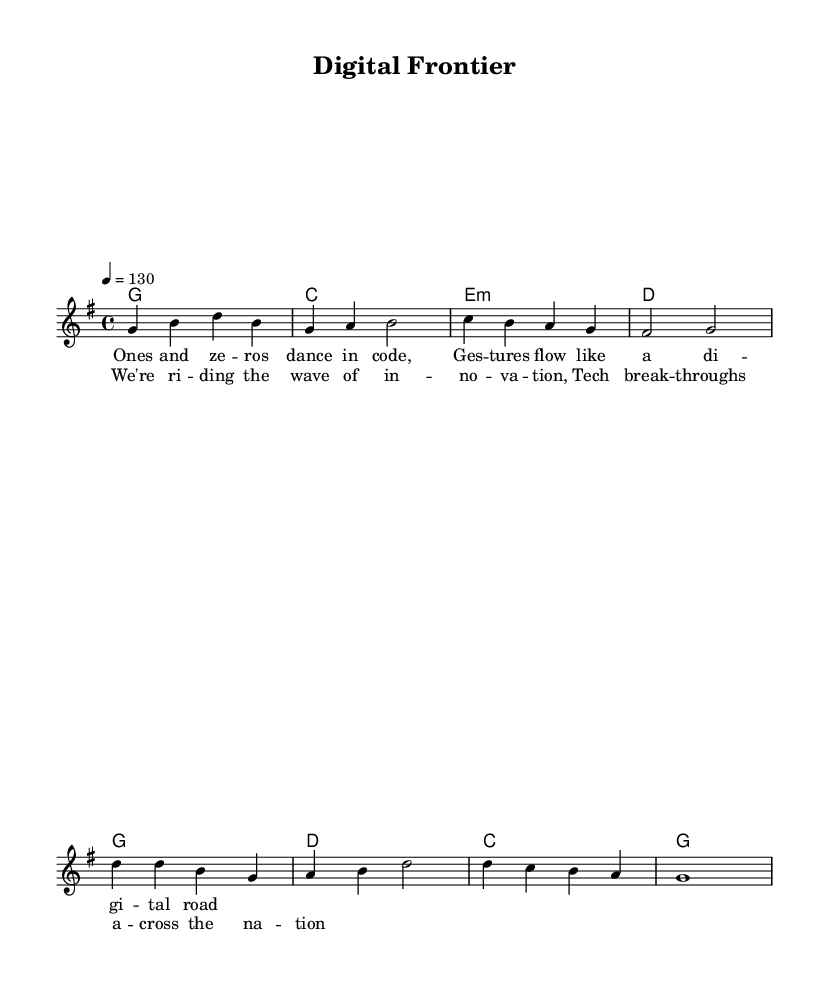What is the key signature of this music? The key signature is G major, indicated by one sharp (F#).
Answer: G major What is the time signature of this music? The time signature is 4/4, meaning there are four beats in each measure, and the quarter note gets one beat.
Answer: 4/4 What is the tempo marking for this piece? The tempo marking indicates a speed of 130 beats per minute, which is stated as "4 = 130."
Answer: 130 How many measures are there in the verse? The verse contains four measures as indicated by the line breaks in the melody section.
Answer: 4 Which chord follows the G chord in the chorus? The chord progression in the chorus indicates that the D chord follows the G chord.
Answer: D What lyrical theme is represented in this song? The song celebrates technological innovation and advances, as reflected in the lyrics about "riding the wave of innovation."
Answer: Innovation In what section does the lyrical content mention "ones and zeros"? The phrase "ones and zeros" is found in the verse, as it describes aspects of coding and technology.
Answer: Verse 